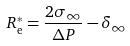Convert formula to latex. <formula><loc_0><loc_0><loc_500><loc_500>R _ { \text  e}^{*} = \frac{2 \sigma_{\infty} } { \Delta P } - \delta _ { \infty }</formula> 